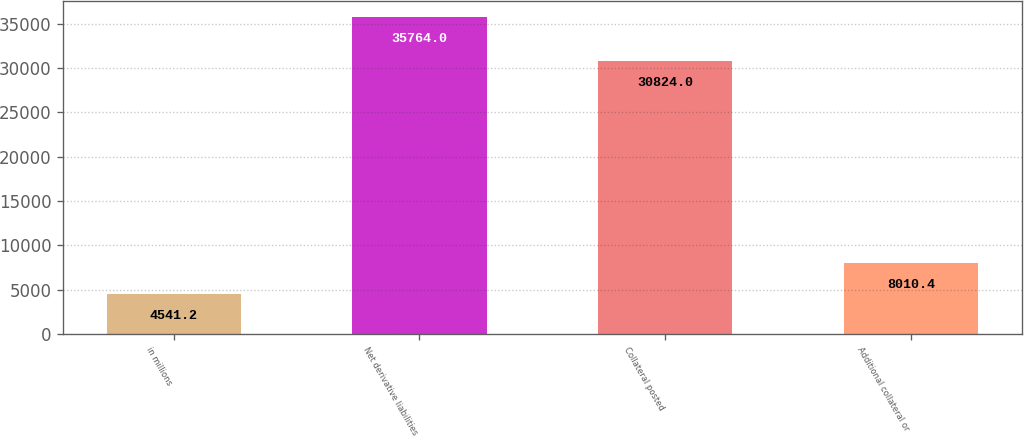Convert chart to OTSL. <chart><loc_0><loc_0><loc_500><loc_500><bar_chart><fcel>in millions<fcel>Net derivative liabilities<fcel>Collateral posted<fcel>Additional collateral or<nl><fcel>4541.2<fcel>35764<fcel>30824<fcel>8010.4<nl></chart> 